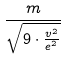Convert formula to latex. <formula><loc_0><loc_0><loc_500><loc_500>\frac { m } { \sqrt { 9 \cdot \frac { v ^ { 2 } } { e ^ { 2 } } } }</formula> 